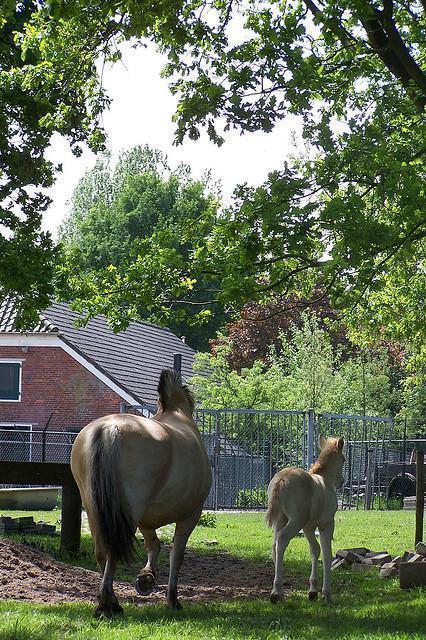What are the horses doing?
From the following four choices, select the correct answer to address the question.
Options: Swimming, sleeping, standing, flying. Standing. 